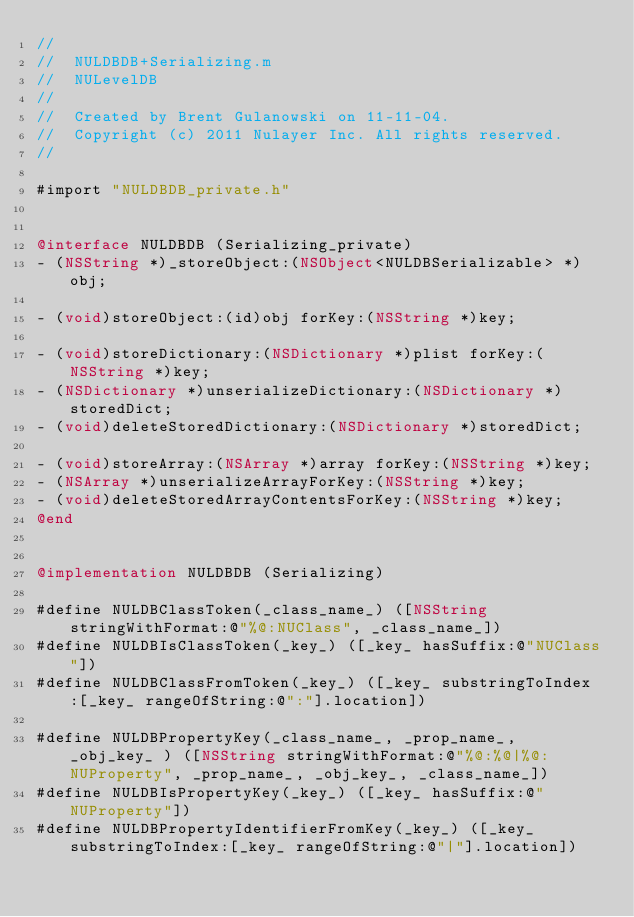Convert code to text. <code><loc_0><loc_0><loc_500><loc_500><_ObjectiveC_>//
//  NULDBDB+Serializing.m
//  NULevelDB
//
//  Created by Brent Gulanowski on 11-11-04.
//  Copyright (c) 2011 Nulayer Inc. All rights reserved.
//

#import "NULDBDB_private.h"


@interface NULDBDB (Serializing_private)
- (NSString *)_storeObject:(NSObject<NULDBSerializable> *)obj;

- (void)storeObject:(id)obj forKey:(NSString *)key;

- (void)storeDictionary:(NSDictionary *)plist forKey:(NSString *)key;
- (NSDictionary *)unserializeDictionary:(NSDictionary *)storedDict;
- (void)deleteStoredDictionary:(NSDictionary *)storedDict;

- (void)storeArray:(NSArray *)array forKey:(NSString *)key;
- (NSArray *)unserializeArrayForKey:(NSString *)key;
- (void)deleteStoredArrayContentsForKey:(NSString *)key;
@end


@implementation NULDBDB (Serializing)

#define NULDBClassToken(_class_name_) ([NSString stringWithFormat:@"%@:NUClass", _class_name_])
#define NULDBIsClassToken(_key_) ([_key_ hasSuffix:@"NUClass"])
#define NULDBClassFromToken(_key_) ([_key_ substringToIndex:[_key_ rangeOfString:@":"].location])

#define NULDBPropertyKey(_class_name_, _prop_name_, _obj_key_ ) ([NSString stringWithFormat:@"%@:%@|%@:NUProperty", _prop_name_, _obj_key_, _class_name_])
#define NULDBIsPropertyKey(_key_) ([_key_ hasSuffix:@"NUProperty"])
#define NULDBPropertyIdentifierFromKey(_key_) ([_key_ substringToIndex:[_key_ rangeOfString:@"|"].location])
</code> 